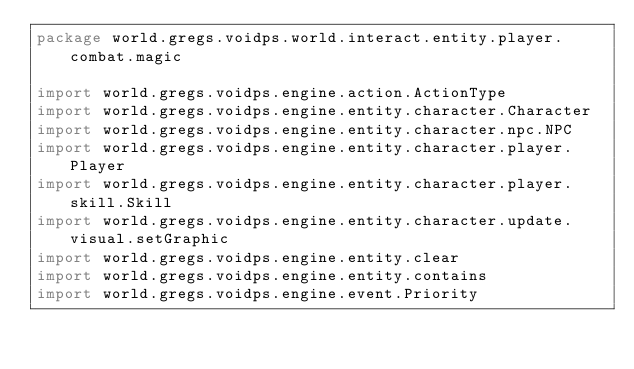Convert code to text. <code><loc_0><loc_0><loc_500><loc_500><_Kotlin_>package world.gregs.voidps.world.interact.entity.player.combat.magic

import world.gregs.voidps.engine.action.ActionType
import world.gregs.voidps.engine.entity.character.Character
import world.gregs.voidps.engine.entity.character.npc.NPC
import world.gregs.voidps.engine.entity.character.player.Player
import world.gregs.voidps.engine.entity.character.player.skill.Skill
import world.gregs.voidps.engine.entity.character.update.visual.setGraphic
import world.gregs.voidps.engine.entity.clear
import world.gregs.voidps.engine.entity.contains
import world.gregs.voidps.engine.event.Priority</code> 